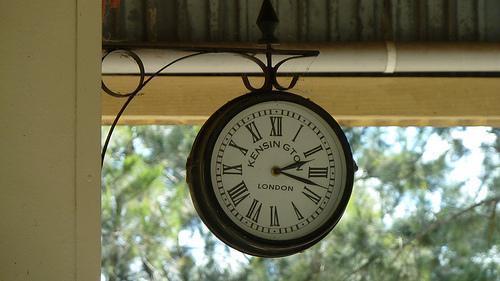How many clocks?
Give a very brief answer. 1. 